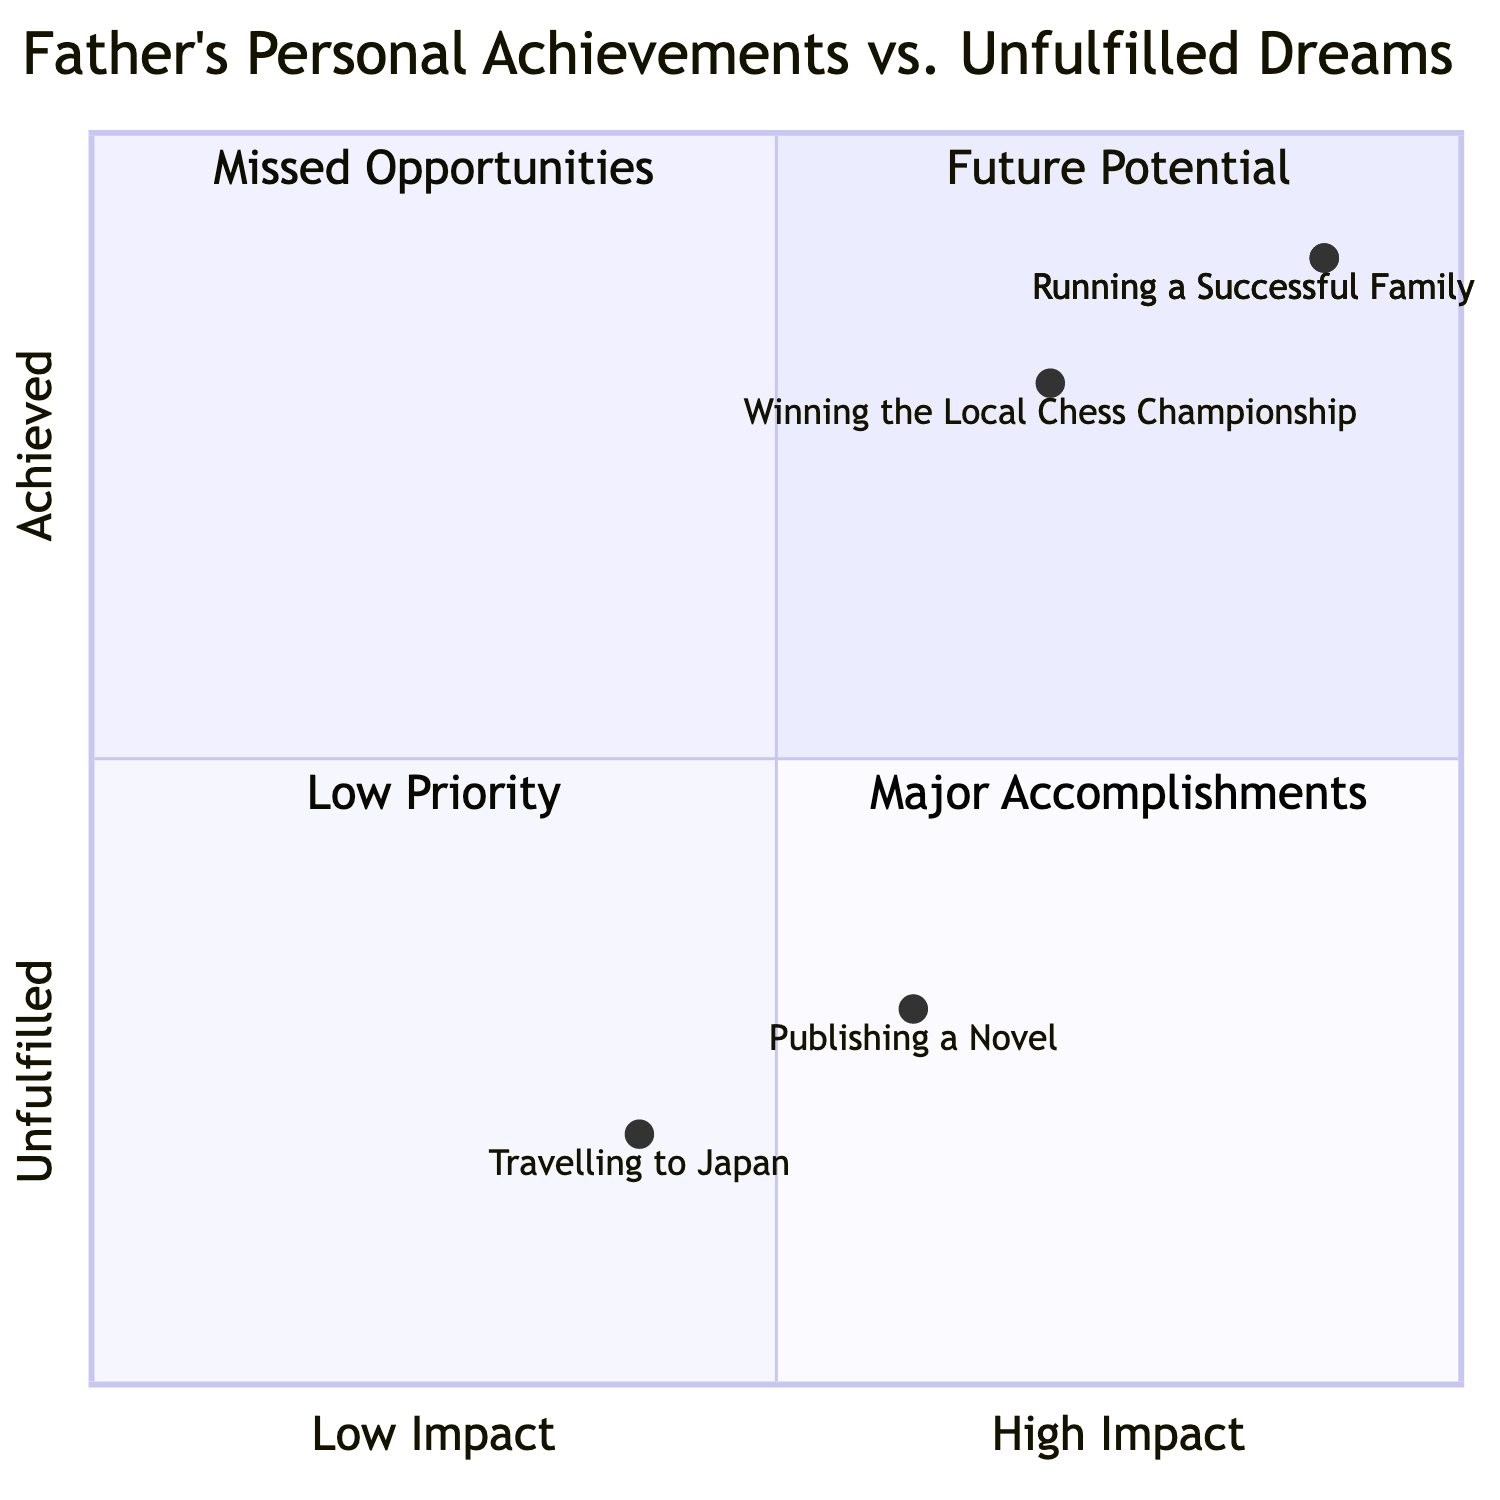What are the names of the two fulfilled personal achievements in the diagram? The diagram lists "Running a Successful Family Business" and "Winning the Local Chess Championship" as the two fulfilled personal achievements.
Answer: Running a Successful Family Business, Winning the Local Chess Championship Which aspiration is placed highest on the quadrant chart? In the quadrant chart, "Running a Successful Family Business" is located at [0.9, 0.9], the highest coordinate value, indicating it is the highest aspiration achieved.
Answer: Running a Successful Family Business How many total aspirations are in the chart? The chart includes a total of four aspirations: two achieved aspirations and two unfulfilled dreams.
Answer: Four Which unfulfilled dream has the highest impact according to the chart? "Publishing a Novel" is at [0.6, 0.3], which is the highest on the x-axis among the unfulfilled dreams.
Answer: Publishing a Novel Which quadrant does "Travelling to Japan" fall into? "Travelling to Japan" is located at [0.4, 0.2], which places it in the "Missed Opportunities" quadrant since it has low achievement and moderate impact.
Answer: Missed Opportunities Which aspiration has the lowest achievement? "Travelling to Japan" is at [0.4, 0.2], which indicates it has the lowest achievement among the aspirations listed in the chart.
Answer: Travelling to Japan Is there a correlation between the impact and achievement of "Running a Successful Family Business"? Yes, "Running a Successful Family Business" has both high impact (0.9) and high achievement (0.9), showing a strong correlation.
Answer: Yes What is the common characteristic of aspirations in the "Major Accomplishments" quadrant? Aspirations in the "Major Accomplishments" quadrant have high impact and achievement, specifically "Running a Successful Family Business" and "Winning the Local Chess Championship."
Answer: High impact and achievement 